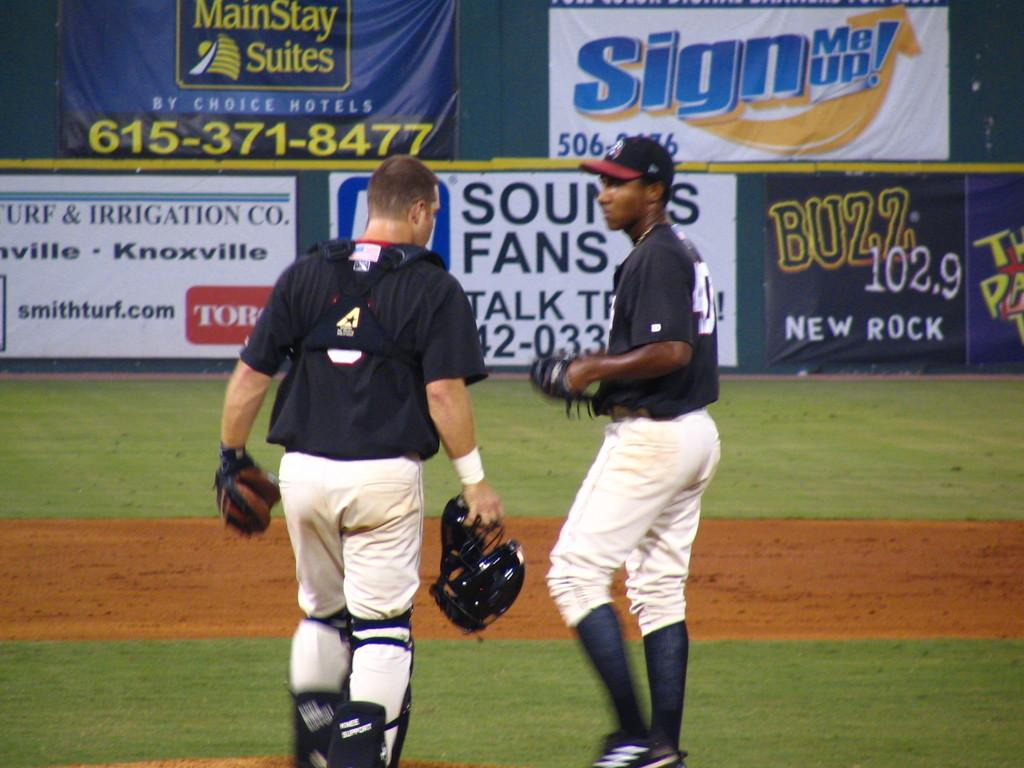<image>
Relay a brief, clear account of the picture shown. Two baseball players confer on the field with a MainStay Suites ad in the background. 